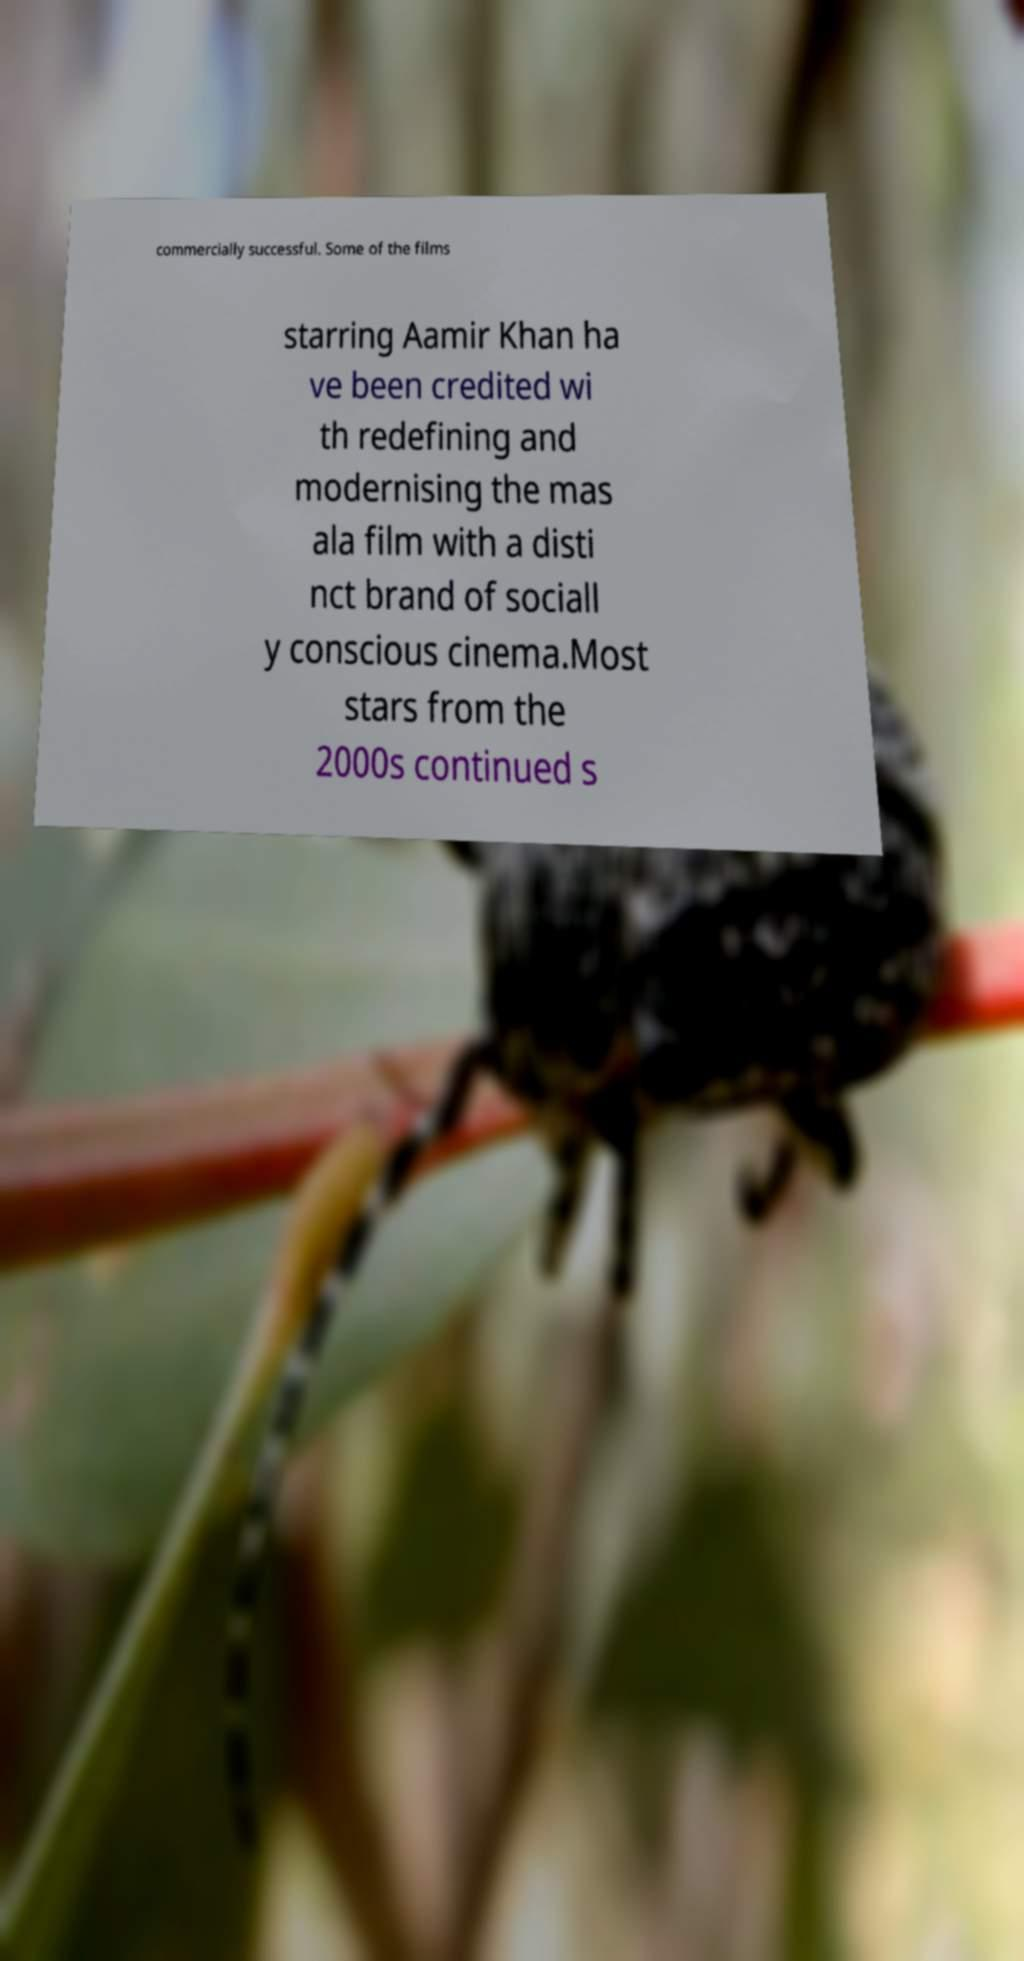Please read and relay the text visible in this image. What does it say? commercially successful. Some of the films starring Aamir Khan ha ve been credited wi th redefining and modernising the mas ala film with a disti nct brand of sociall y conscious cinema.Most stars from the 2000s continued s 